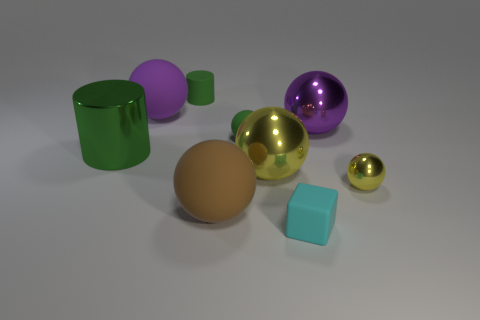Is there any other thing that has the same size as the green shiny cylinder?
Your answer should be compact. Yes. The yellow object that is in front of the yellow sphere on the left side of the tiny cyan thing is what shape?
Your answer should be very brief. Sphere. Is the material of the big ball that is to the right of the matte block the same as the small green object that is to the left of the large brown ball?
Your response must be concise. No. There is a big shiny thing that is in front of the large cylinder; what number of cyan cubes are to the right of it?
Your answer should be very brief. 1. Is the shape of the shiny thing behind the green shiny object the same as the purple thing that is on the left side of the small cyan cube?
Offer a very short reply. Yes. There is a green thing that is both right of the big green metal thing and in front of the big purple rubber thing; what is its size?
Provide a short and direct response. Small. The other small object that is the same shape as the small metallic thing is what color?
Provide a short and direct response. Green. What color is the matte cylinder that is left of the small green thing that is to the right of the big brown matte sphere?
Ensure brevity in your answer.  Green. What is the shape of the large brown matte object?
Ensure brevity in your answer.  Sphere. There is a metallic thing that is both to the right of the purple rubber sphere and on the left side of the purple metallic sphere; what is its shape?
Offer a terse response. Sphere. 